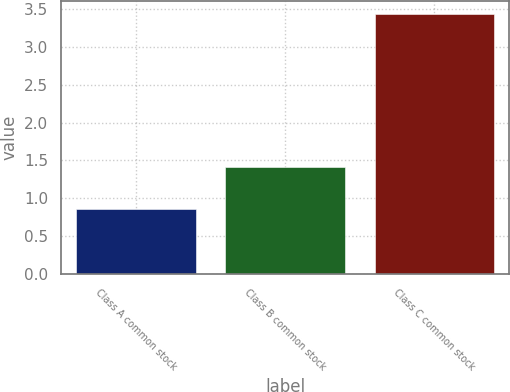<chart> <loc_0><loc_0><loc_500><loc_500><bar_chart><fcel>Class A common stock<fcel>Class B common stock<fcel>Class C common stock<nl><fcel>0.86<fcel>1.41<fcel>3.43<nl></chart> 